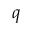Convert formula to latex. <formula><loc_0><loc_0><loc_500><loc_500>q</formula> 